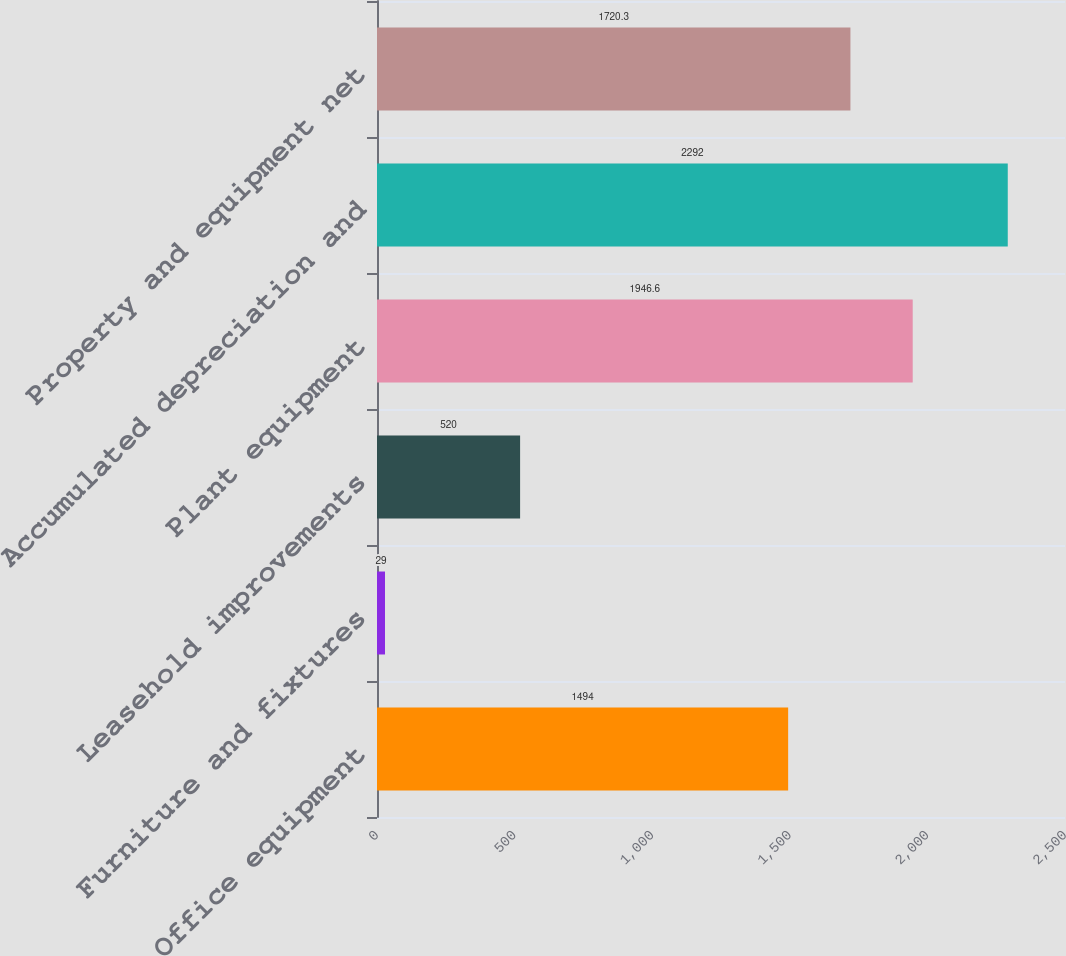Convert chart to OTSL. <chart><loc_0><loc_0><loc_500><loc_500><bar_chart><fcel>Office equipment<fcel>Furniture and fixtures<fcel>Leasehold improvements<fcel>Plant equipment<fcel>Accumulated depreciation and<fcel>Property and equipment net<nl><fcel>1494<fcel>29<fcel>520<fcel>1946.6<fcel>2292<fcel>1720.3<nl></chart> 